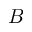<formula> <loc_0><loc_0><loc_500><loc_500>B</formula> 